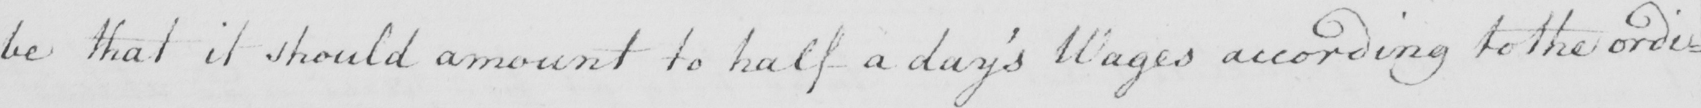Can you tell me what this handwritten text says? be that it should amount to half a day ' s Wages according to the ordi= 